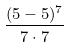Convert formula to latex. <formula><loc_0><loc_0><loc_500><loc_500>\frac { ( 5 - 5 ) ^ { 7 } } { 7 \cdot 7 }</formula> 